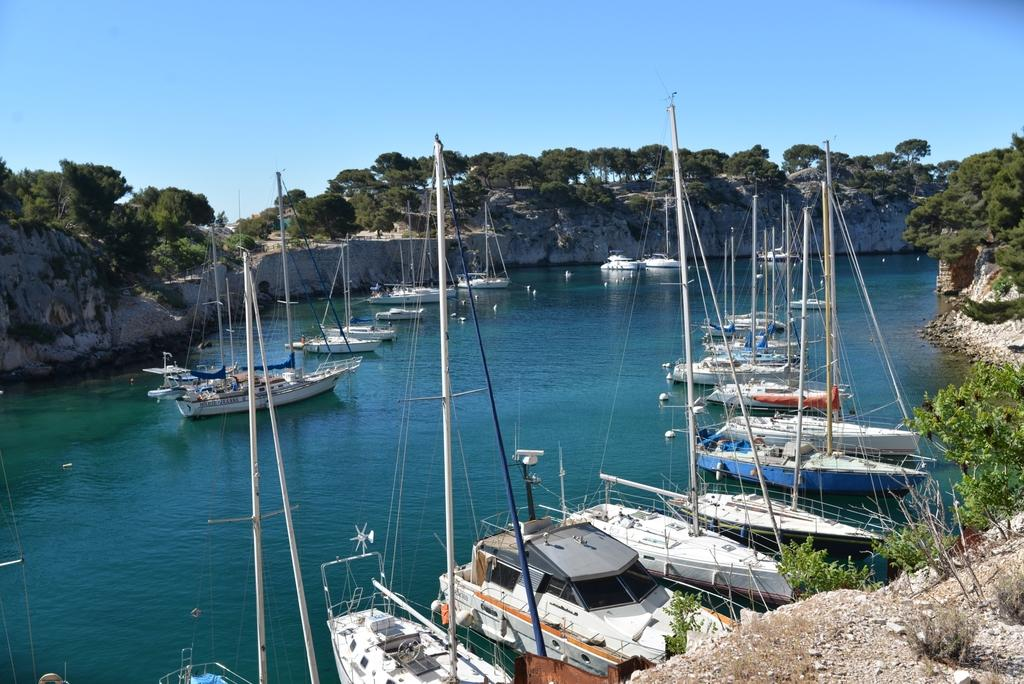What can be seen floating on the water in the image? There are boats in the image. What is the color of the water in the image? The water is blue in color. What is located near the water in the image? There are rocks and trees near the water in the image. What is visible in the background of the image? The sky is visible in the background of the image. What type of disease is affecting the ants in the image? There are no ants present in the image, so it is not possible to determine if any disease is affecting them. 